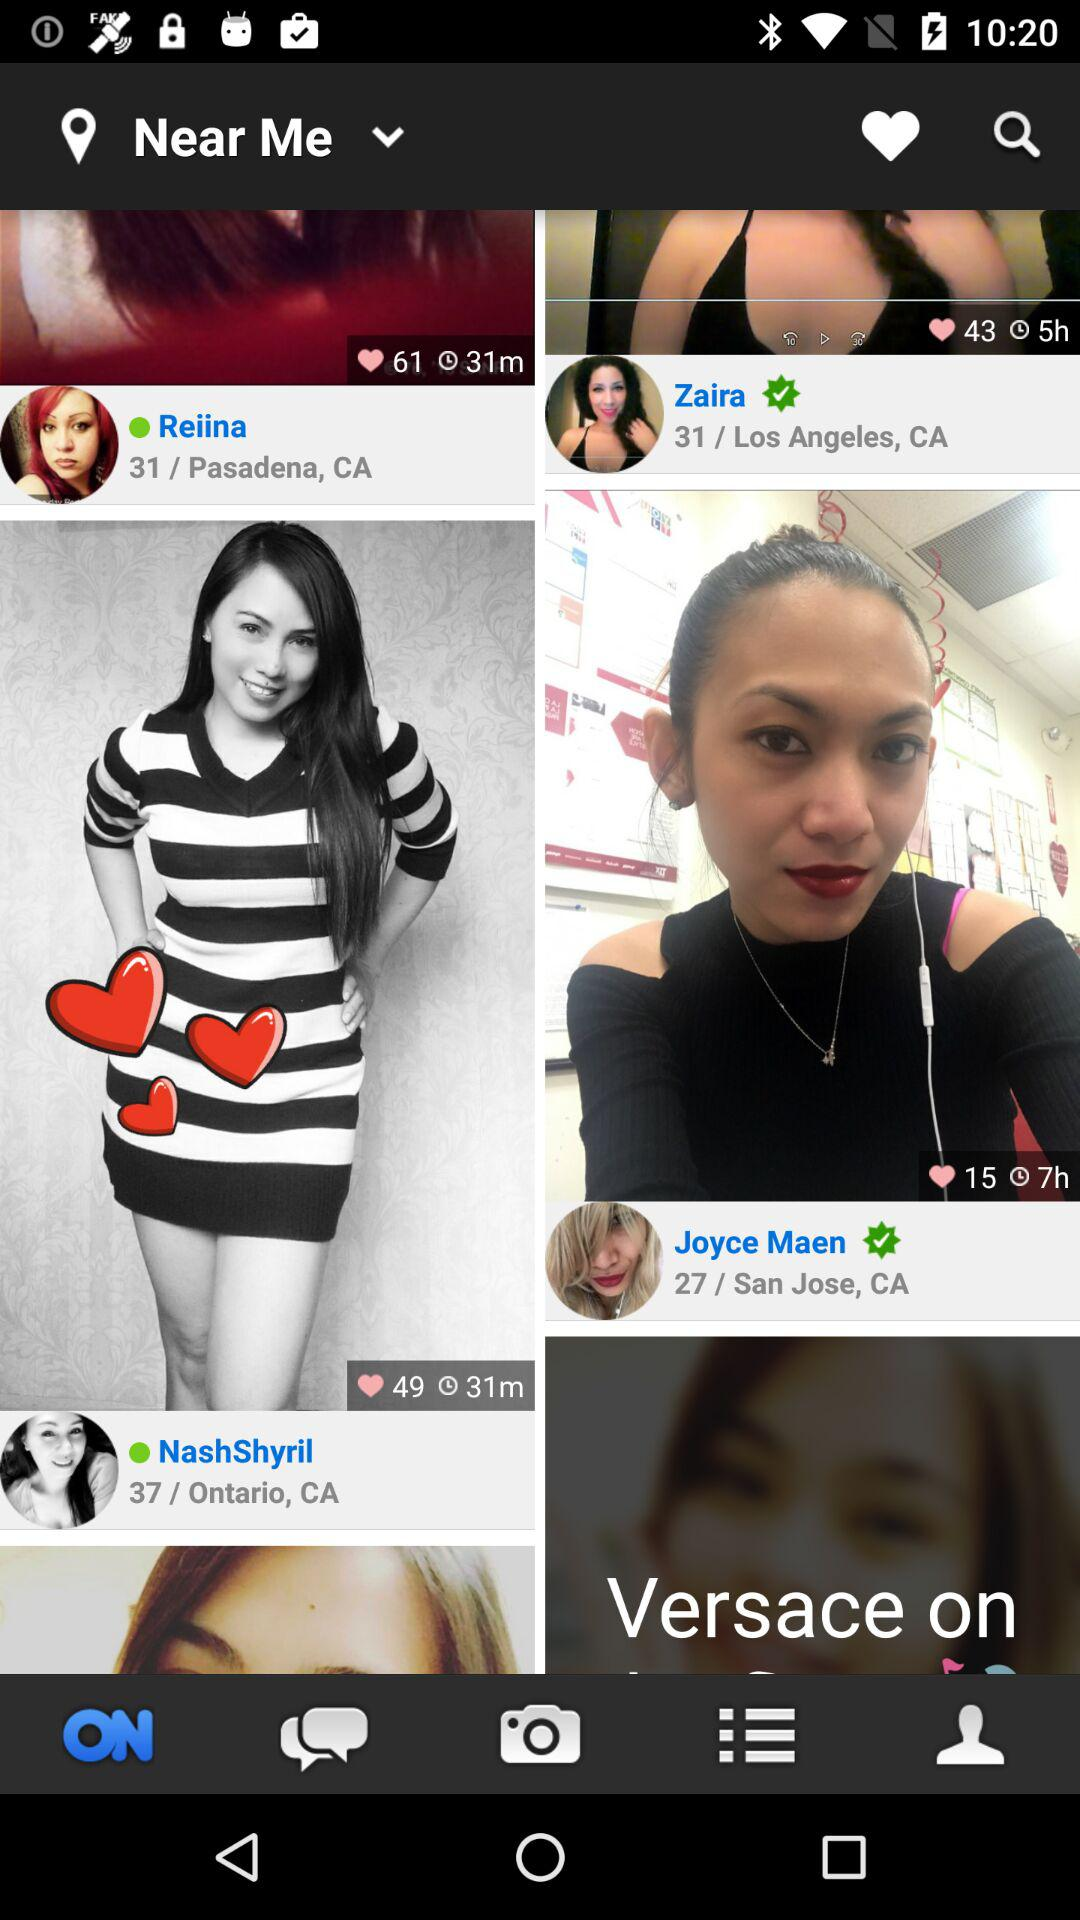What is the age of Zaira? The age of Zaira is 31. 